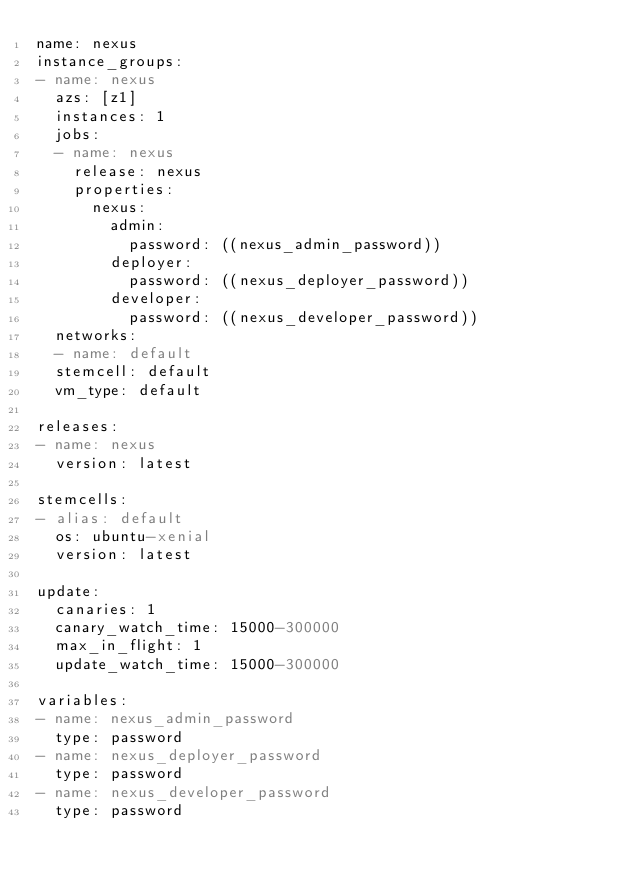Convert code to text. <code><loc_0><loc_0><loc_500><loc_500><_YAML_>name: nexus
instance_groups:
- name: nexus
  azs: [z1]
  instances: 1
  jobs:
  - name: nexus
    release: nexus
    properties:
      nexus:
        admin:
          password: ((nexus_admin_password))
        deployer:
          password: ((nexus_deployer_password))
        developer:
          password: ((nexus_developer_password))
  networks:
  - name: default
  stemcell: default
  vm_type: default

releases:
- name: nexus
  version: latest

stemcells:
- alias: default
  os: ubuntu-xenial
  version: latest

update:
  canaries: 1
  canary_watch_time: 15000-300000
  max_in_flight: 1
  update_watch_time: 15000-300000

variables:
- name: nexus_admin_password
  type: password
- name: nexus_deployer_password
  type: password
- name: nexus_developer_password
  type: password
</code> 